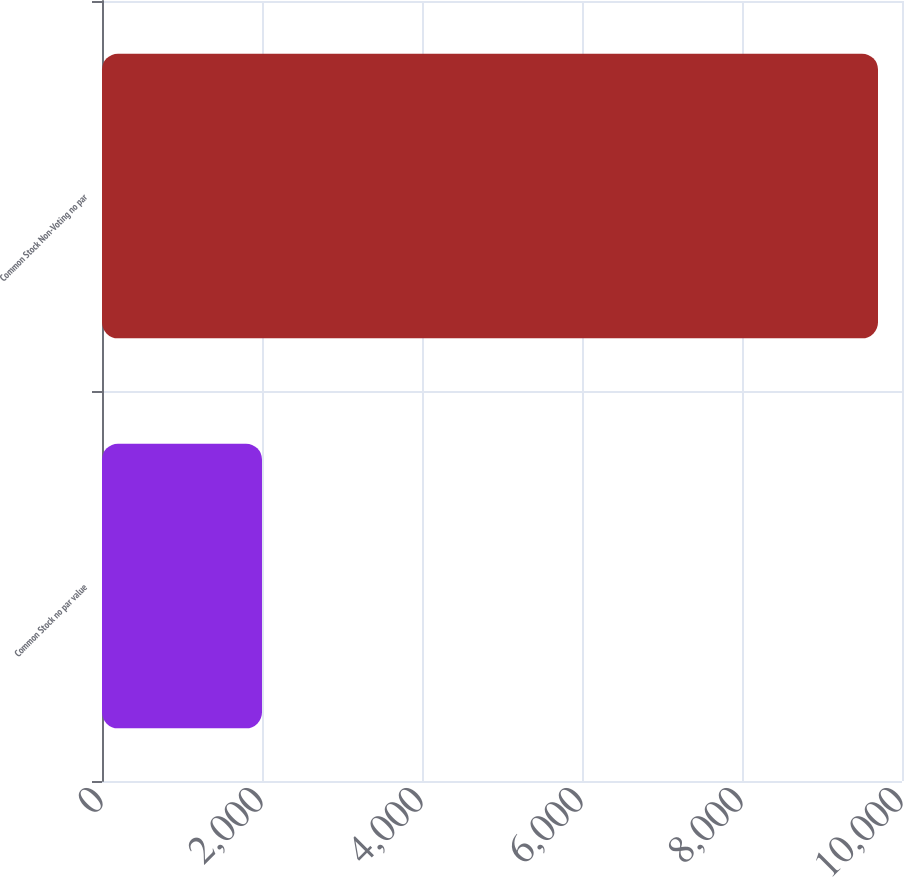Convert chart to OTSL. <chart><loc_0><loc_0><loc_500><loc_500><bar_chart><fcel>Common Stock no par value<fcel>Common Stock Non-Voting no par<nl><fcel>2000<fcel>9700<nl></chart> 